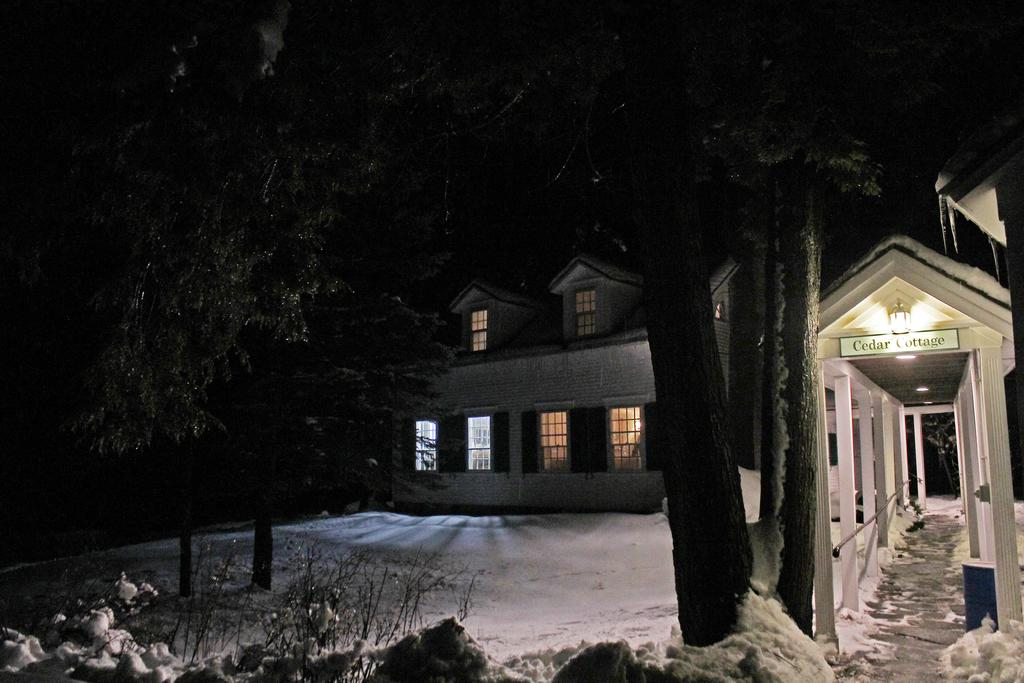What type of vegetation can be seen in the image? There are plants and trees in the image. What is the condition of the land in the image? The land in the image is covered with snow. What can be seen in the background of the image? There is a building in the background of the image. What feature of the building is mentioned in the facts? The building has windows. What type of cream is being offered by the tree in the image? There is no cream being offered by the tree in the image; it is a plant or tree with no such activity. Can you see a pipe connecting the building to the tree in the image? There is no pipe connecting the building to the tree in the image; the facts only mention the presence of plants, trees, snow, and a building with windows. 